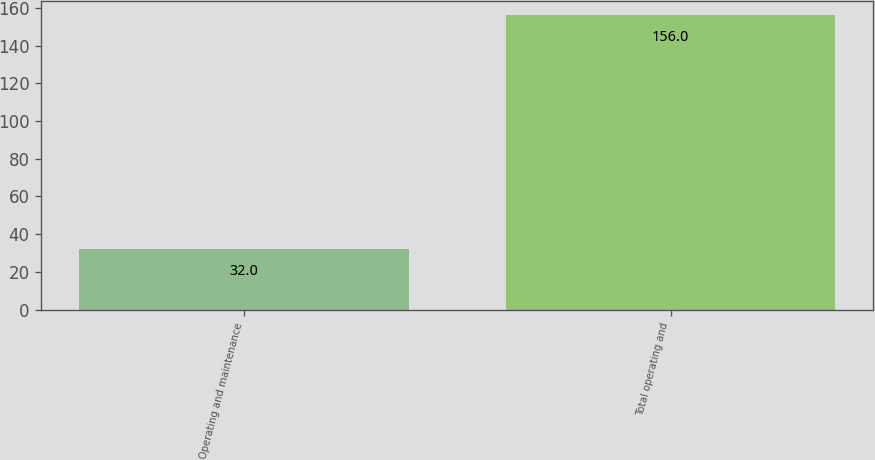<chart> <loc_0><loc_0><loc_500><loc_500><bar_chart><fcel>Operating and maintenance<fcel>Total operating and<nl><fcel>32<fcel>156<nl></chart> 